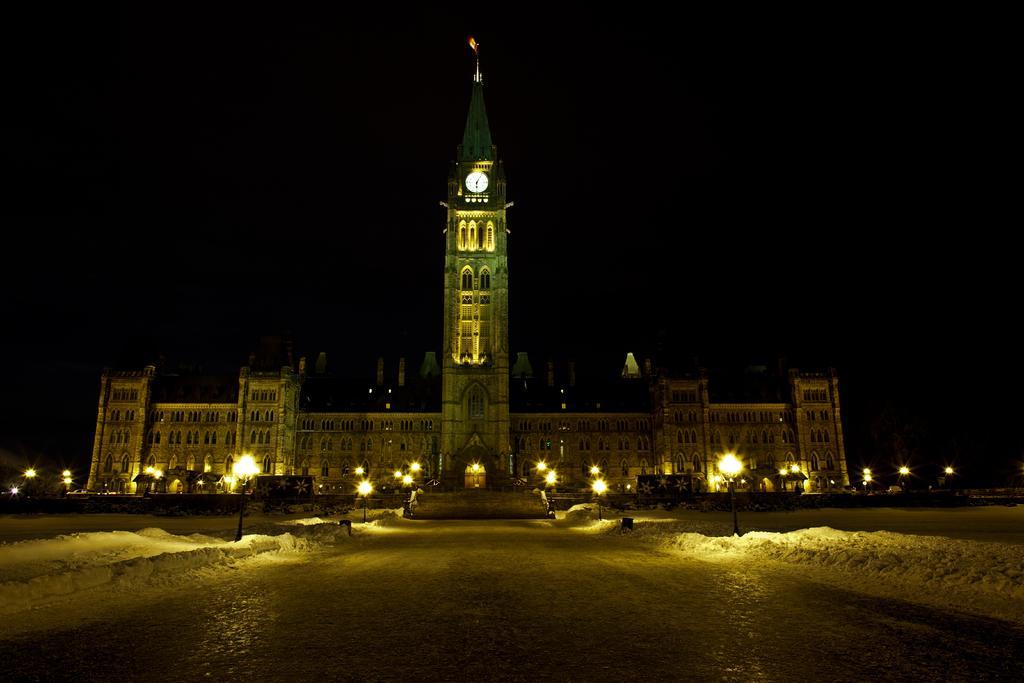How would you summarize this image in a sentence or two? In this image, we can see a building, walls, tower, lights and few objects. Here we can see a clock on the tower. Background we can see the dark view. At the bottom, there is a road. 